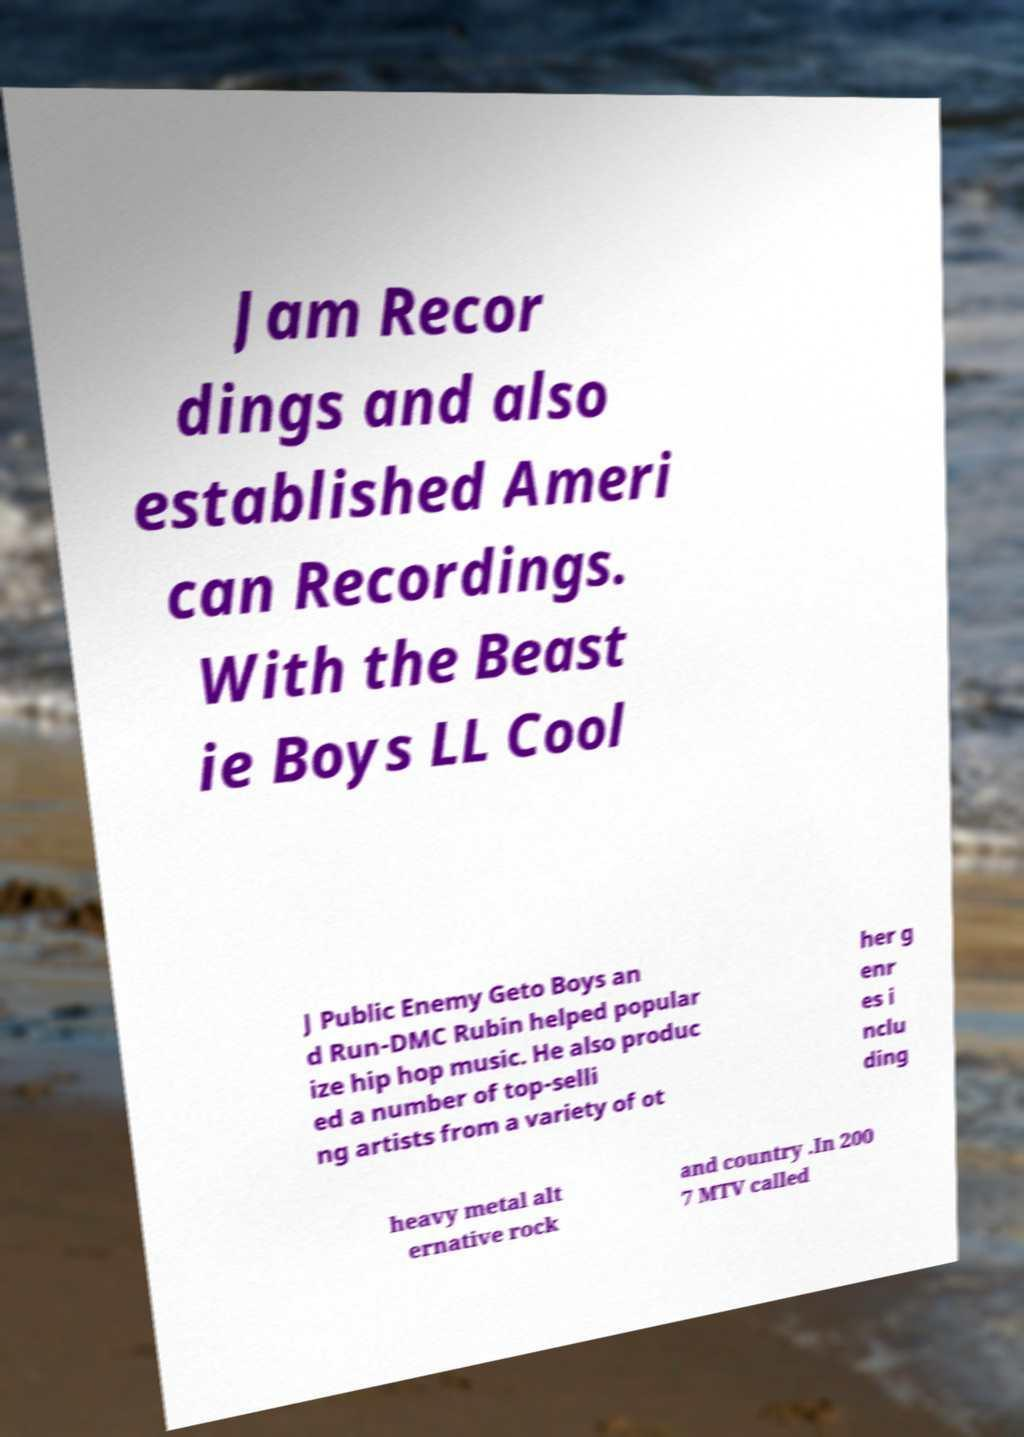What messages or text are displayed in this image? I need them in a readable, typed format. Jam Recor dings and also established Ameri can Recordings. With the Beast ie Boys LL Cool J Public Enemy Geto Boys an d Run-DMC Rubin helped popular ize hip hop music. He also produc ed a number of top-selli ng artists from a variety of ot her g enr es i nclu ding heavy metal alt ernative rock and country .In 200 7 MTV called 